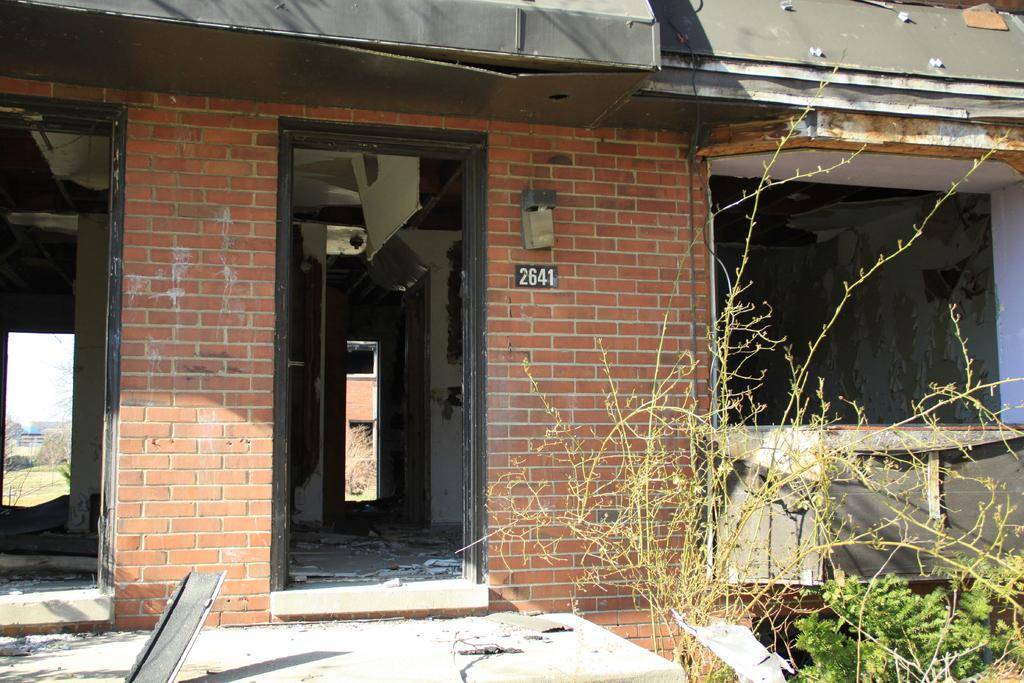What type of building is visible in the image? There is a building with a brick wall in the image. Is there any specific detail on the wall of the building? Yes, there is a number on the wall. What can be seen on the right side of the image? There are plants on the right side of the image. What type of war is being depicted in the image? There is no depiction of a war in the image; it features a building with a brick wall, a number on the wall, and plants on the right side. 